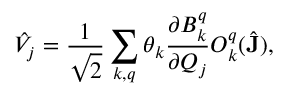Convert formula to latex. <formula><loc_0><loc_0><loc_500><loc_500>\hat { V } _ { j } = \frac { 1 } { \sqrt { 2 } } \sum _ { k , q } \theta _ { k } \frac { \partial B _ { k } ^ { q } } { \partial Q _ { j } } O _ { k } ^ { q } ( \hat { J } ) ,</formula> 